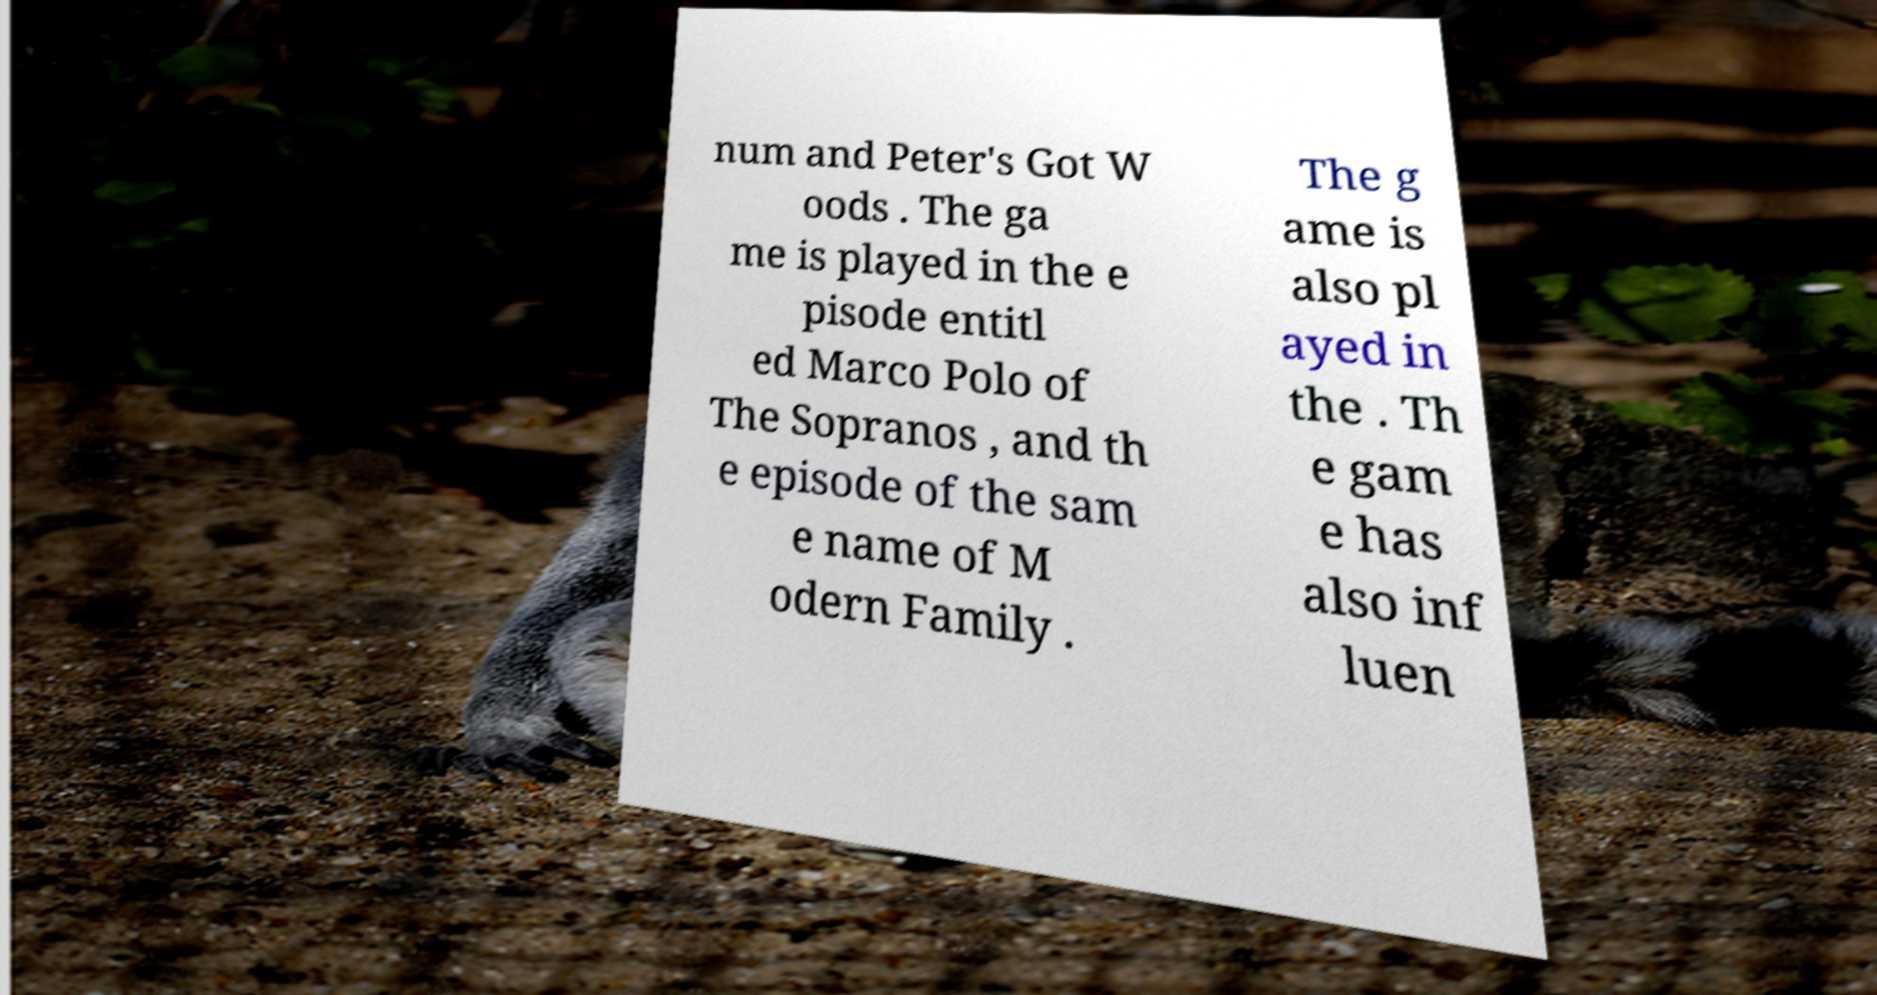Could you extract and type out the text from this image? num and Peter's Got W oods . The ga me is played in the e pisode entitl ed Marco Polo of The Sopranos , and th e episode of the sam e name of M odern Family . The g ame is also pl ayed in the . Th e gam e has also inf luen 